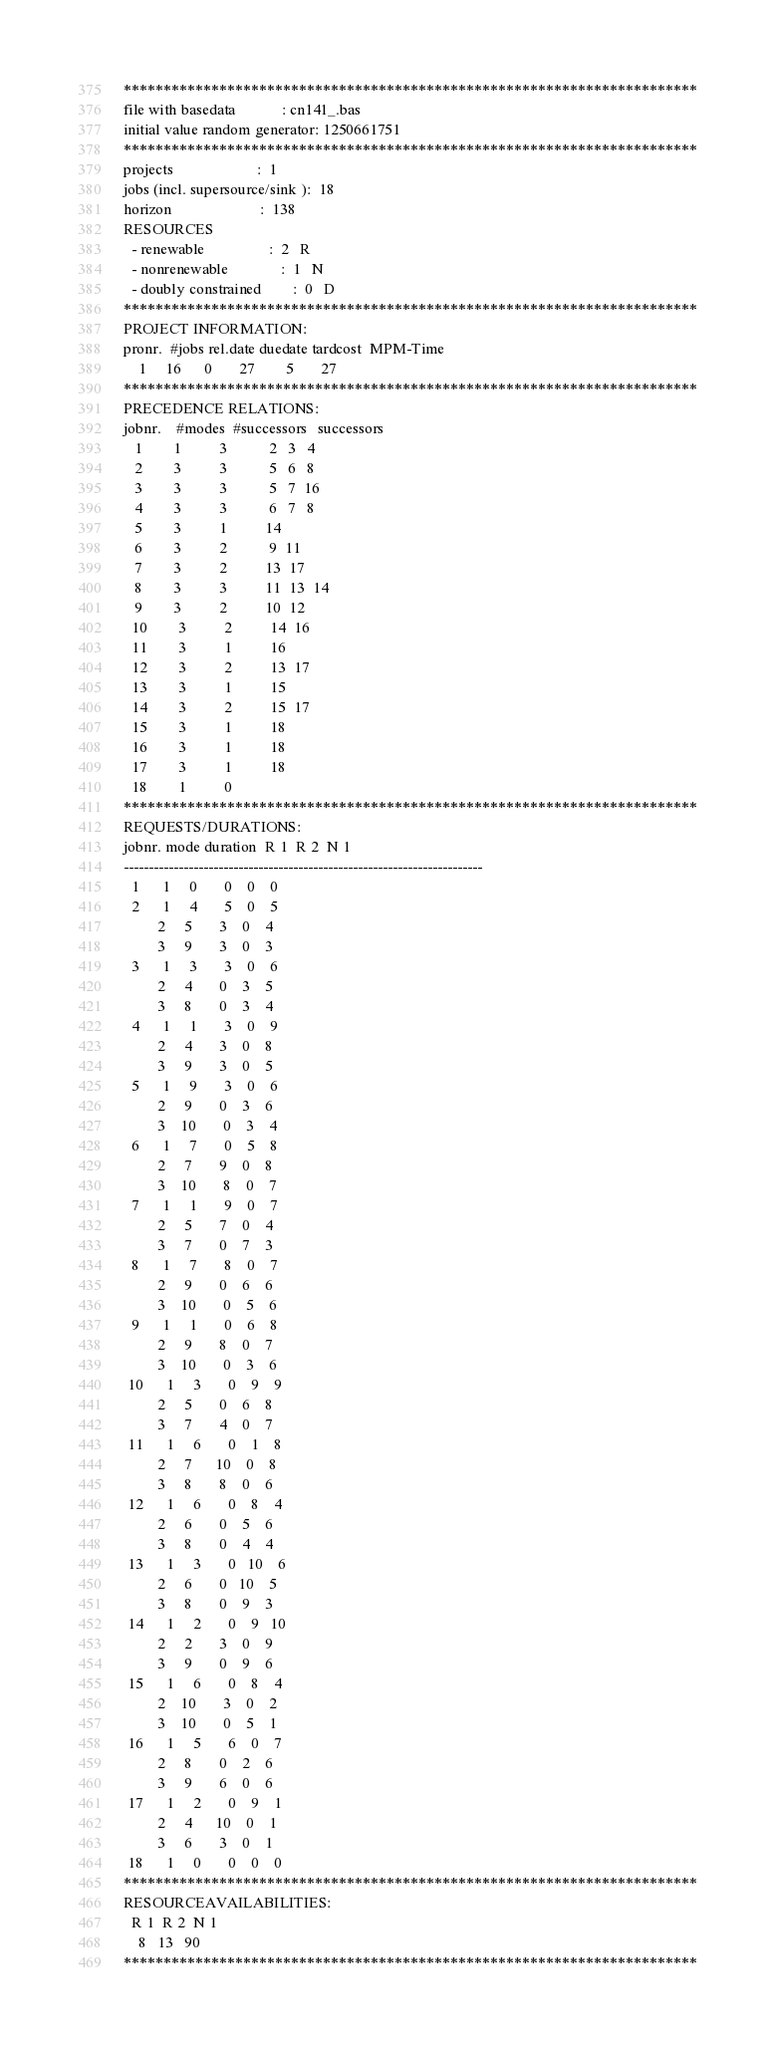<code> <loc_0><loc_0><loc_500><loc_500><_ObjectiveC_>************************************************************************
file with basedata            : cn141_.bas
initial value random generator: 1250661751
************************************************************************
projects                      :  1
jobs (incl. supersource/sink ):  18
horizon                       :  138
RESOURCES
  - renewable                 :  2   R
  - nonrenewable              :  1   N
  - doubly constrained        :  0   D
************************************************************************
PROJECT INFORMATION:
pronr.  #jobs rel.date duedate tardcost  MPM-Time
    1     16      0       27        5       27
************************************************************************
PRECEDENCE RELATIONS:
jobnr.    #modes  #successors   successors
   1        1          3           2   3   4
   2        3          3           5   6   8
   3        3          3           5   7  16
   4        3          3           6   7   8
   5        3          1          14
   6        3          2           9  11
   7        3          2          13  17
   8        3          3          11  13  14
   9        3          2          10  12
  10        3          2          14  16
  11        3          1          16
  12        3          2          13  17
  13        3          1          15
  14        3          2          15  17
  15        3          1          18
  16        3          1          18
  17        3          1          18
  18        1          0        
************************************************************************
REQUESTS/DURATIONS:
jobnr. mode duration  R 1  R 2  N 1
------------------------------------------------------------------------
  1      1     0       0    0    0
  2      1     4       5    0    5
         2     5       3    0    4
         3     9       3    0    3
  3      1     3       3    0    6
         2     4       0    3    5
         3     8       0    3    4
  4      1     1       3    0    9
         2     4       3    0    8
         3     9       3    0    5
  5      1     9       3    0    6
         2     9       0    3    6
         3    10       0    3    4
  6      1     7       0    5    8
         2     7       9    0    8
         3    10       8    0    7
  7      1     1       9    0    7
         2     5       7    0    4
         3     7       0    7    3
  8      1     7       8    0    7
         2     9       0    6    6
         3    10       0    5    6
  9      1     1       0    6    8
         2     9       8    0    7
         3    10       0    3    6
 10      1     3       0    9    9
         2     5       0    6    8
         3     7       4    0    7
 11      1     6       0    1    8
         2     7      10    0    8
         3     8       8    0    6
 12      1     6       0    8    4
         2     6       0    5    6
         3     8       0    4    4
 13      1     3       0   10    6
         2     6       0   10    5
         3     8       0    9    3
 14      1     2       0    9   10
         2     2       3    0    9
         3     9       0    9    6
 15      1     6       0    8    4
         2    10       3    0    2
         3    10       0    5    1
 16      1     5       6    0    7
         2     8       0    2    6
         3     9       6    0    6
 17      1     2       0    9    1
         2     4      10    0    1
         3     6       3    0    1
 18      1     0       0    0    0
************************************************************************
RESOURCEAVAILABILITIES:
  R 1  R 2  N 1
    8   13   90
************************************************************************
</code> 